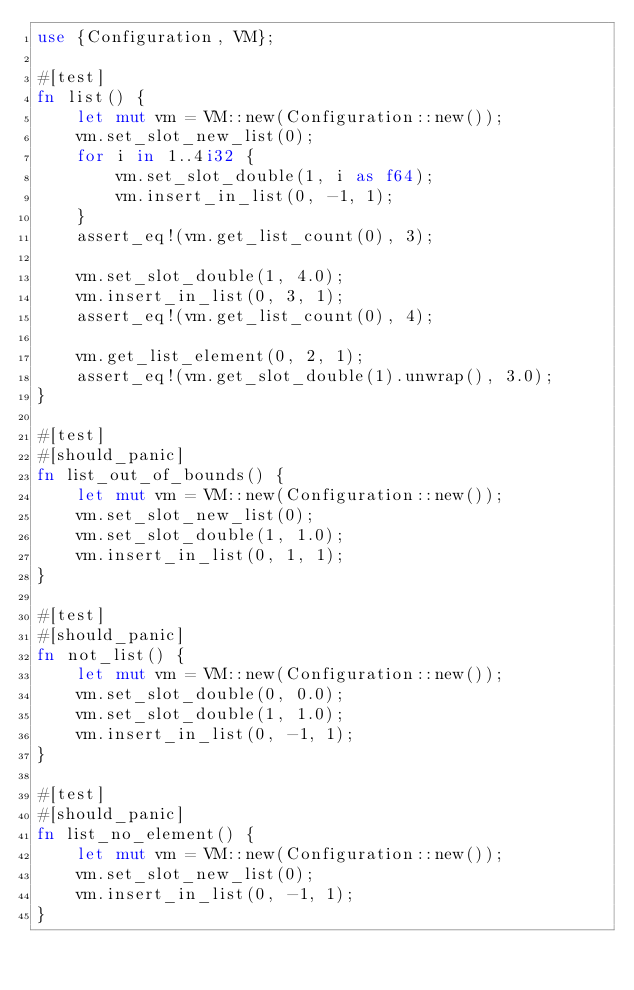<code> <loc_0><loc_0><loc_500><loc_500><_Rust_>use {Configuration, VM};

#[test]
fn list() {
    let mut vm = VM::new(Configuration::new());
    vm.set_slot_new_list(0);
    for i in 1..4i32 {
        vm.set_slot_double(1, i as f64);
        vm.insert_in_list(0, -1, 1);
    }
    assert_eq!(vm.get_list_count(0), 3);

    vm.set_slot_double(1, 4.0);
    vm.insert_in_list(0, 3, 1);
    assert_eq!(vm.get_list_count(0), 4);

    vm.get_list_element(0, 2, 1);
    assert_eq!(vm.get_slot_double(1).unwrap(), 3.0);
}

#[test]
#[should_panic]
fn list_out_of_bounds() {
    let mut vm = VM::new(Configuration::new());
    vm.set_slot_new_list(0);
    vm.set_slot_double(1, 1.0);
    vm.insert_in_list(0, 1, 1);
}

#[test]
#[should_panic]
fn not_list() {
    let mut vm = VM::new(Configuration::new());
    vm.set_slot_double(0, 0.0);
    vm.set_slot_double(1, 1.0);
    vm.insert_in_list(0, -1, 1);
}

#[test]
#[should_panic]
fn list_no_element() {
    let mut vm = VM::new(Configuration::new());
    vm.set_slot_new_list(0);
    vm.insert_in_list(0, -1, 1);
}
</code> 